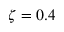Convert formula to latex. <formula><loc_0><loc_0><loc_500><loc_500>\zeta = 0 . 4</formula> 